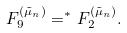<formula> <loc_0><loc_0><loc_500><loc_500>F _ { 9 } ^ { ( \tilde { \mu } _ { n } ) } = ^ { * } F _ { 2 } ^ { ( \tilde { \mu } _ { n } ) } .</formula> 